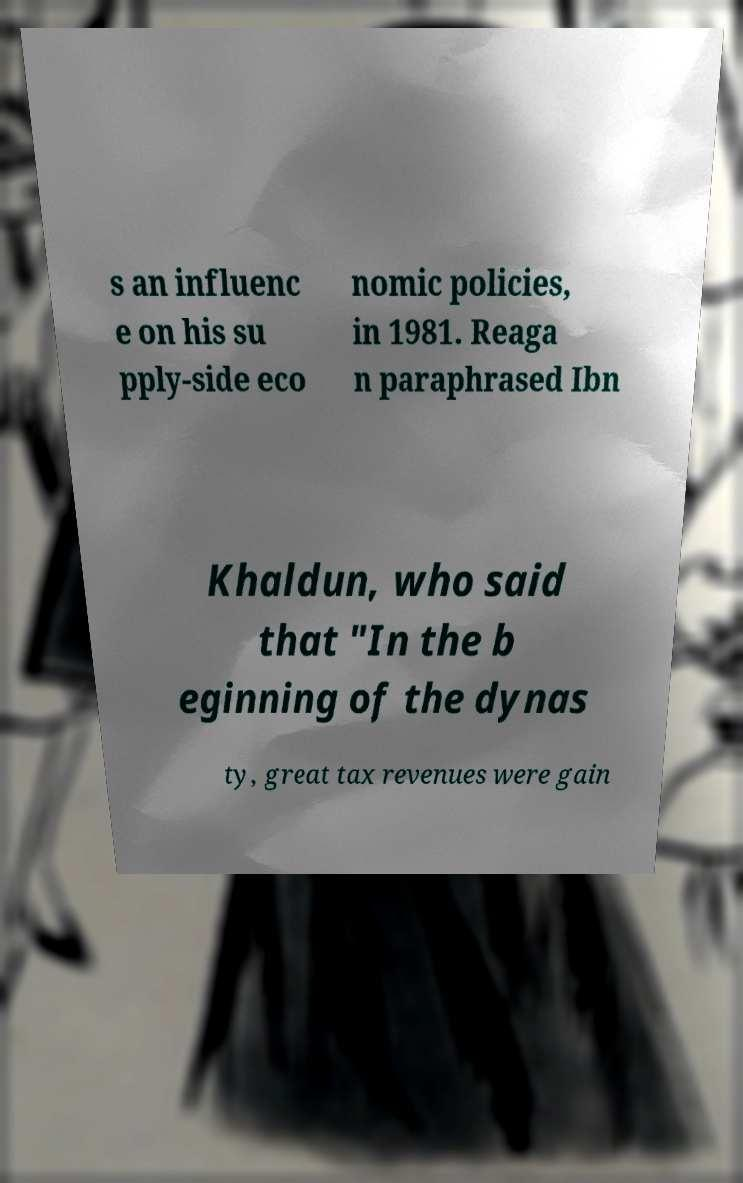I need the written content from this picture converted into text. Can you do that? s an influenc e on his su pply-side eco nomic policies, in 1981. Reaga n paraphrased Ibn Khaldun, who said that "In the b eginning of the dynas ty, great tax revenues were gain 